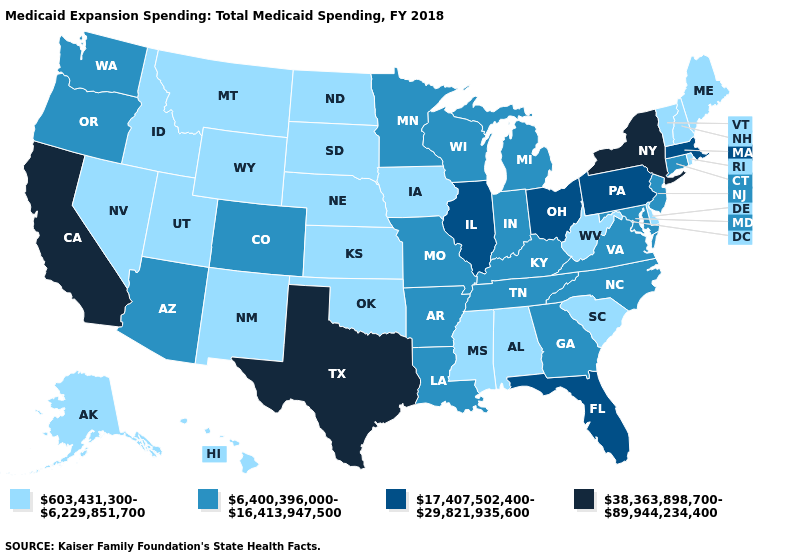Which states have the highest value in the USA?
Be succinct. California, New York, Texas. What is the value of Iowa?
Be succinct. 603,431,300-6,229,851,700. Does the first symbol in the legend represent the smallest category?
Write a very short answer. Yes. What is the value of Nebraska?
Short answer required. 603,431,300-6,229,851,700. Does New Hampshire have the same value as Oregon?
Give a very brief answer. No. What is the value of Mississippi?
Be succinct. 603,431,300-6,229,851,700. Among the states that border Colorado , which have the highest value?
Be succinct. Arizona. What is the lowest value in the South?
Give a very brief answer. 603,431,300-6,229,851,700. What is the highest value in states that border Mississippi?
Be succinct. 6,400,396,000-16,413,947,500. Does Tennessee have the highest value in the USA?
Keep it brief. No. Name the states that have a value in the range 38,363,898,700-89,944,234,400?
Write a very short answer. California, New York, Texas. Among the states that border Arizona , does California have the highest value?
Concise answer only. Yes. What is the value of Arkansas?
Short answer required. 6,400,396,000-16,413,947,500. What is the lowest value in the South?
Short answer required. 603,431,300-6,229,851,700. Does Louisiana have the same value as Washington?
Answer briefly. Yes. 